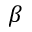Convert formula to latex. <formula><loc_0><loc_0><loc_500><loc_500>\beta</formula> 